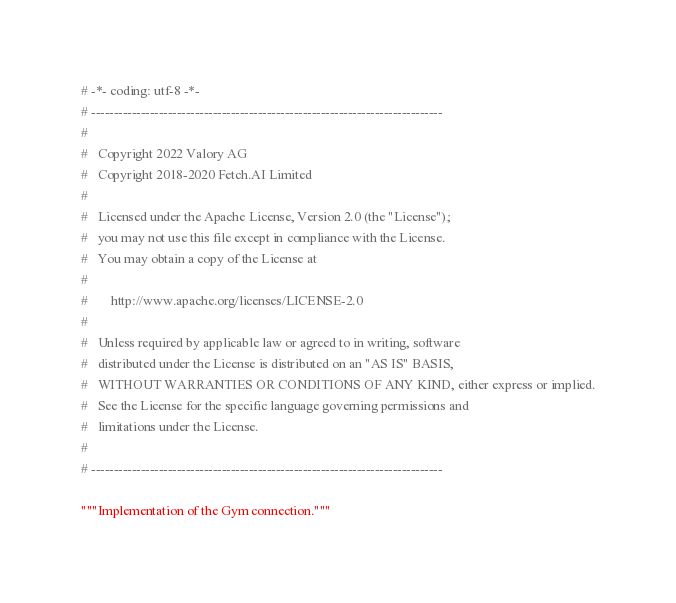<code> <loc_0><loc_0><loc_500><loc_500><_Python_># -*- coding: utf-8 -*-
# ------------------------------------------------------------------------------
#
#   Copyright 2022 Valory AG
#   Copyright 2018-2020 Fetch.AI Limited
#
#   Licensed under the Apache License, Version 2.0 (the "License");
#   you may not use this file except in compliance with the License.
#   You may obtain a copy of the License at
#
#       http://www.apache.org/licenses/LICENSE-2.0
#
#   Unless required by applicable law or agreed to in writing, software
#   distributed under the License is distributed on an "AS IS" BASIS,
#   WITHOUT WARRANTIES OR CONDITIONS OF ANY KIND, either express or implied.
#   See the License for the specific language governing permissions and
#   limitations under the License.
#
# ------------------------------------------------------------------------------

"""Implementation of the Gym connection."""
</code> 